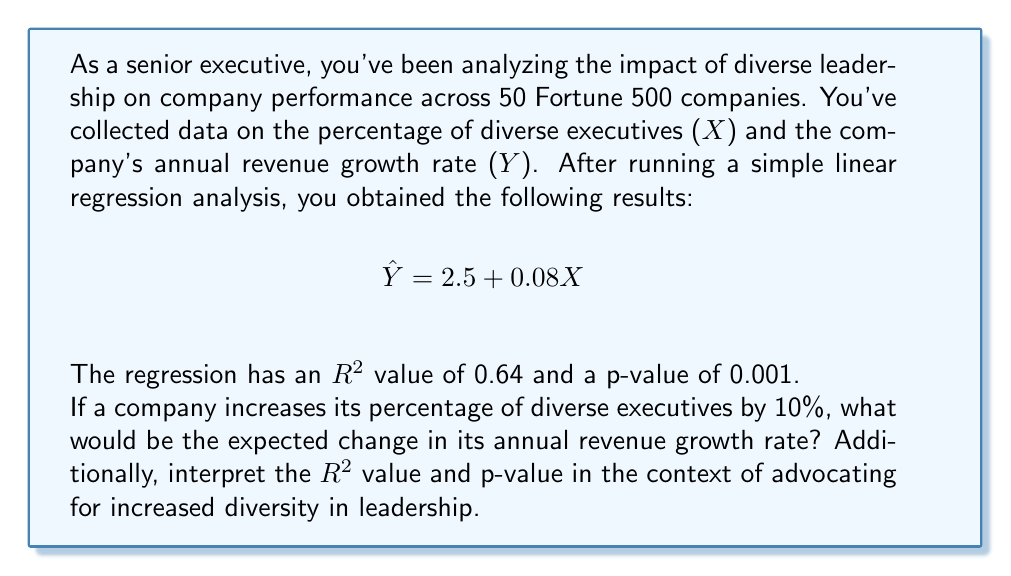What is the answer to this math problem? Let's approach this step-by-step:

1) The regression equation is:
   $$\hat{Y} = 2.5 + 0.08X$$
   Where X is the percentage of diverse executives and Y is the annual revenue growth rate.

2) To find the change in Y for a 10% increase in X, we need to calculate:
   $$\Delta Y = 0.08 * \Delta X$$
   $$\Delta Y = 0.08 * 10 = 0.8$$

3) This means that for a 10% increase in diverse executives, we expect a 0.8 percentage point increase in annual revenue growth rate.

4) Interpreting $R^2$:
   - $R^2 = 0.64$ means that 64% of the variance in annual revenue growth rate can be explained by the percentage of diverse executives.
   - This suggests a strong relationship between diversity in leadership and company performance.

5) Interpreting p-value:
   - p-value = 0.001 < 0.05 (common significance level)
   - This indicates that the relationship between diverse leadership and company performance is statistically significant.
   - The probability of observing such a strong relationship by chance is very low (0.1%).

6) Advocacy interpretation:
   - The strong $R^2$ and low p-value provide compelling evidence to support increased diversity in leadership.
   - We can argue that diversity is not just an ethical imperative but also a business performance driver.
Answer: 0.8 percentage point increase in annual revenue growth rate; $R^2$ and p-value indicate a strong, statistically significant relationship between diversity and performance. 